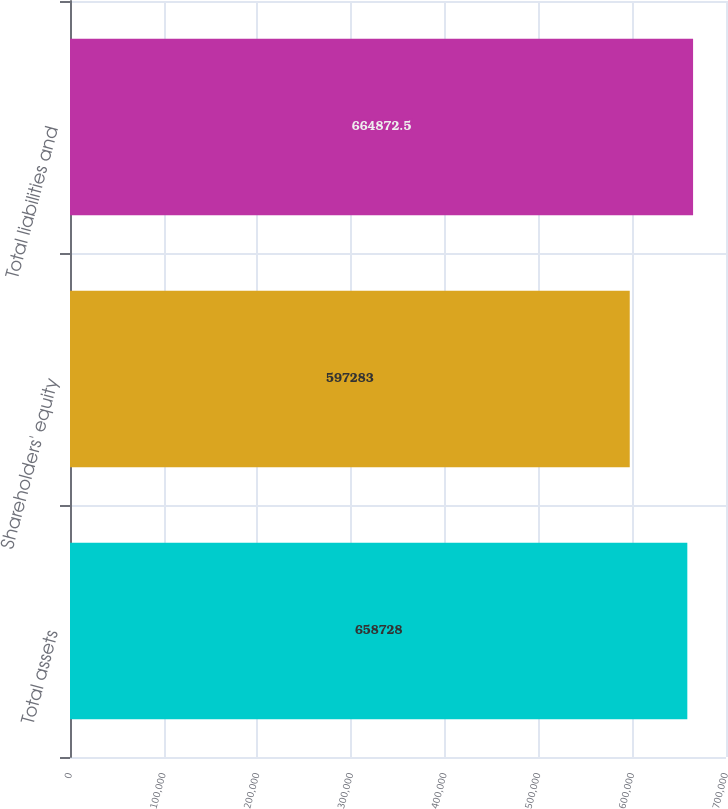Convert chart to OTSL. <chart><loc_0><loc_0><loc_500><loc_500><bar_chart><fcel>Total assets<fcel>Shareholders' equity<fcel>Total liabilities and<nl><fcel>658728<fcel>597283<fcel>664872<nl></chart> 